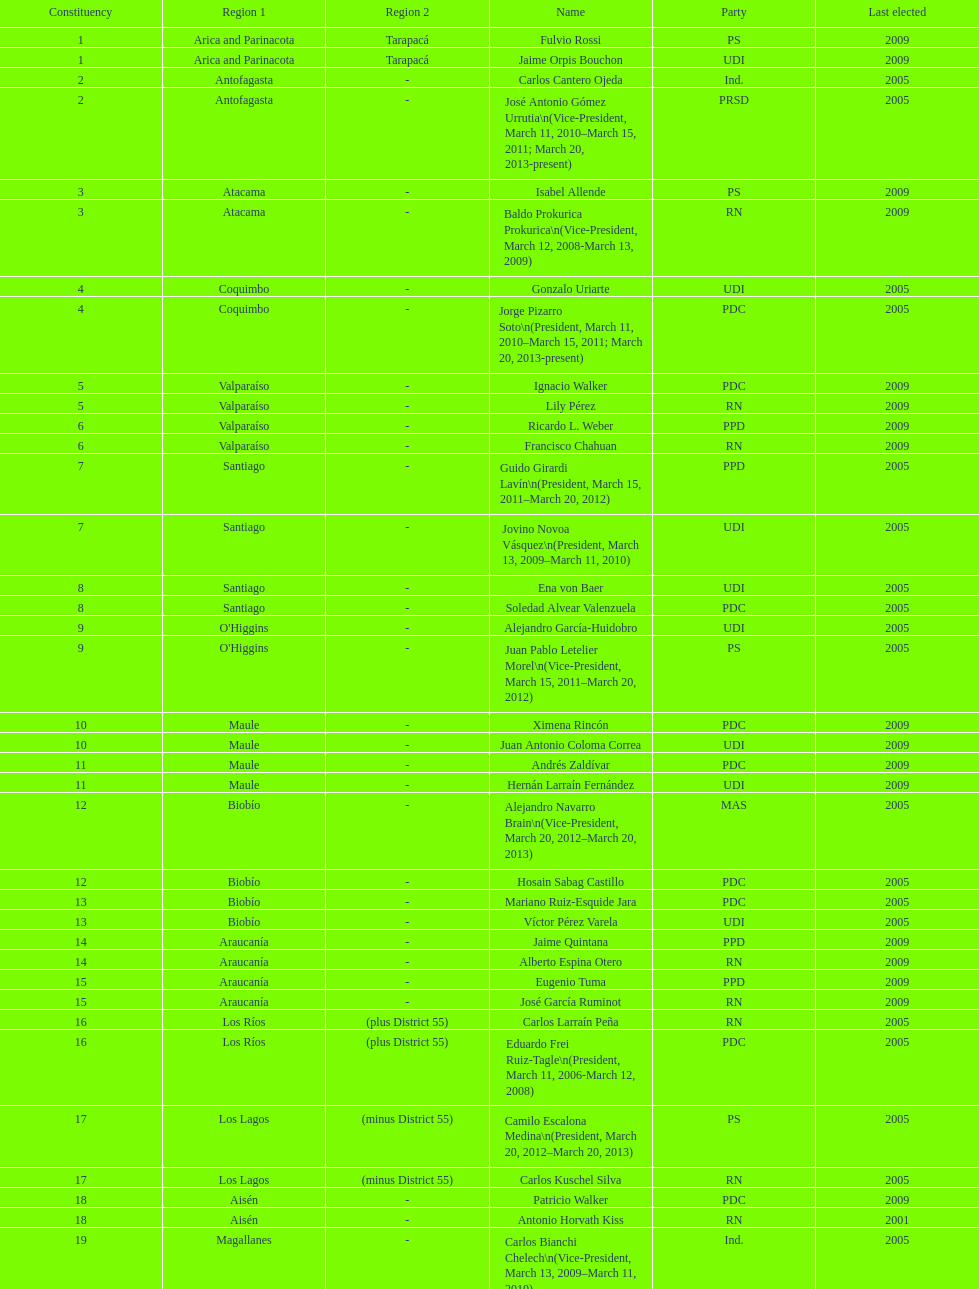What is the difference in years between constiuency 1 and 2? 4 years. 